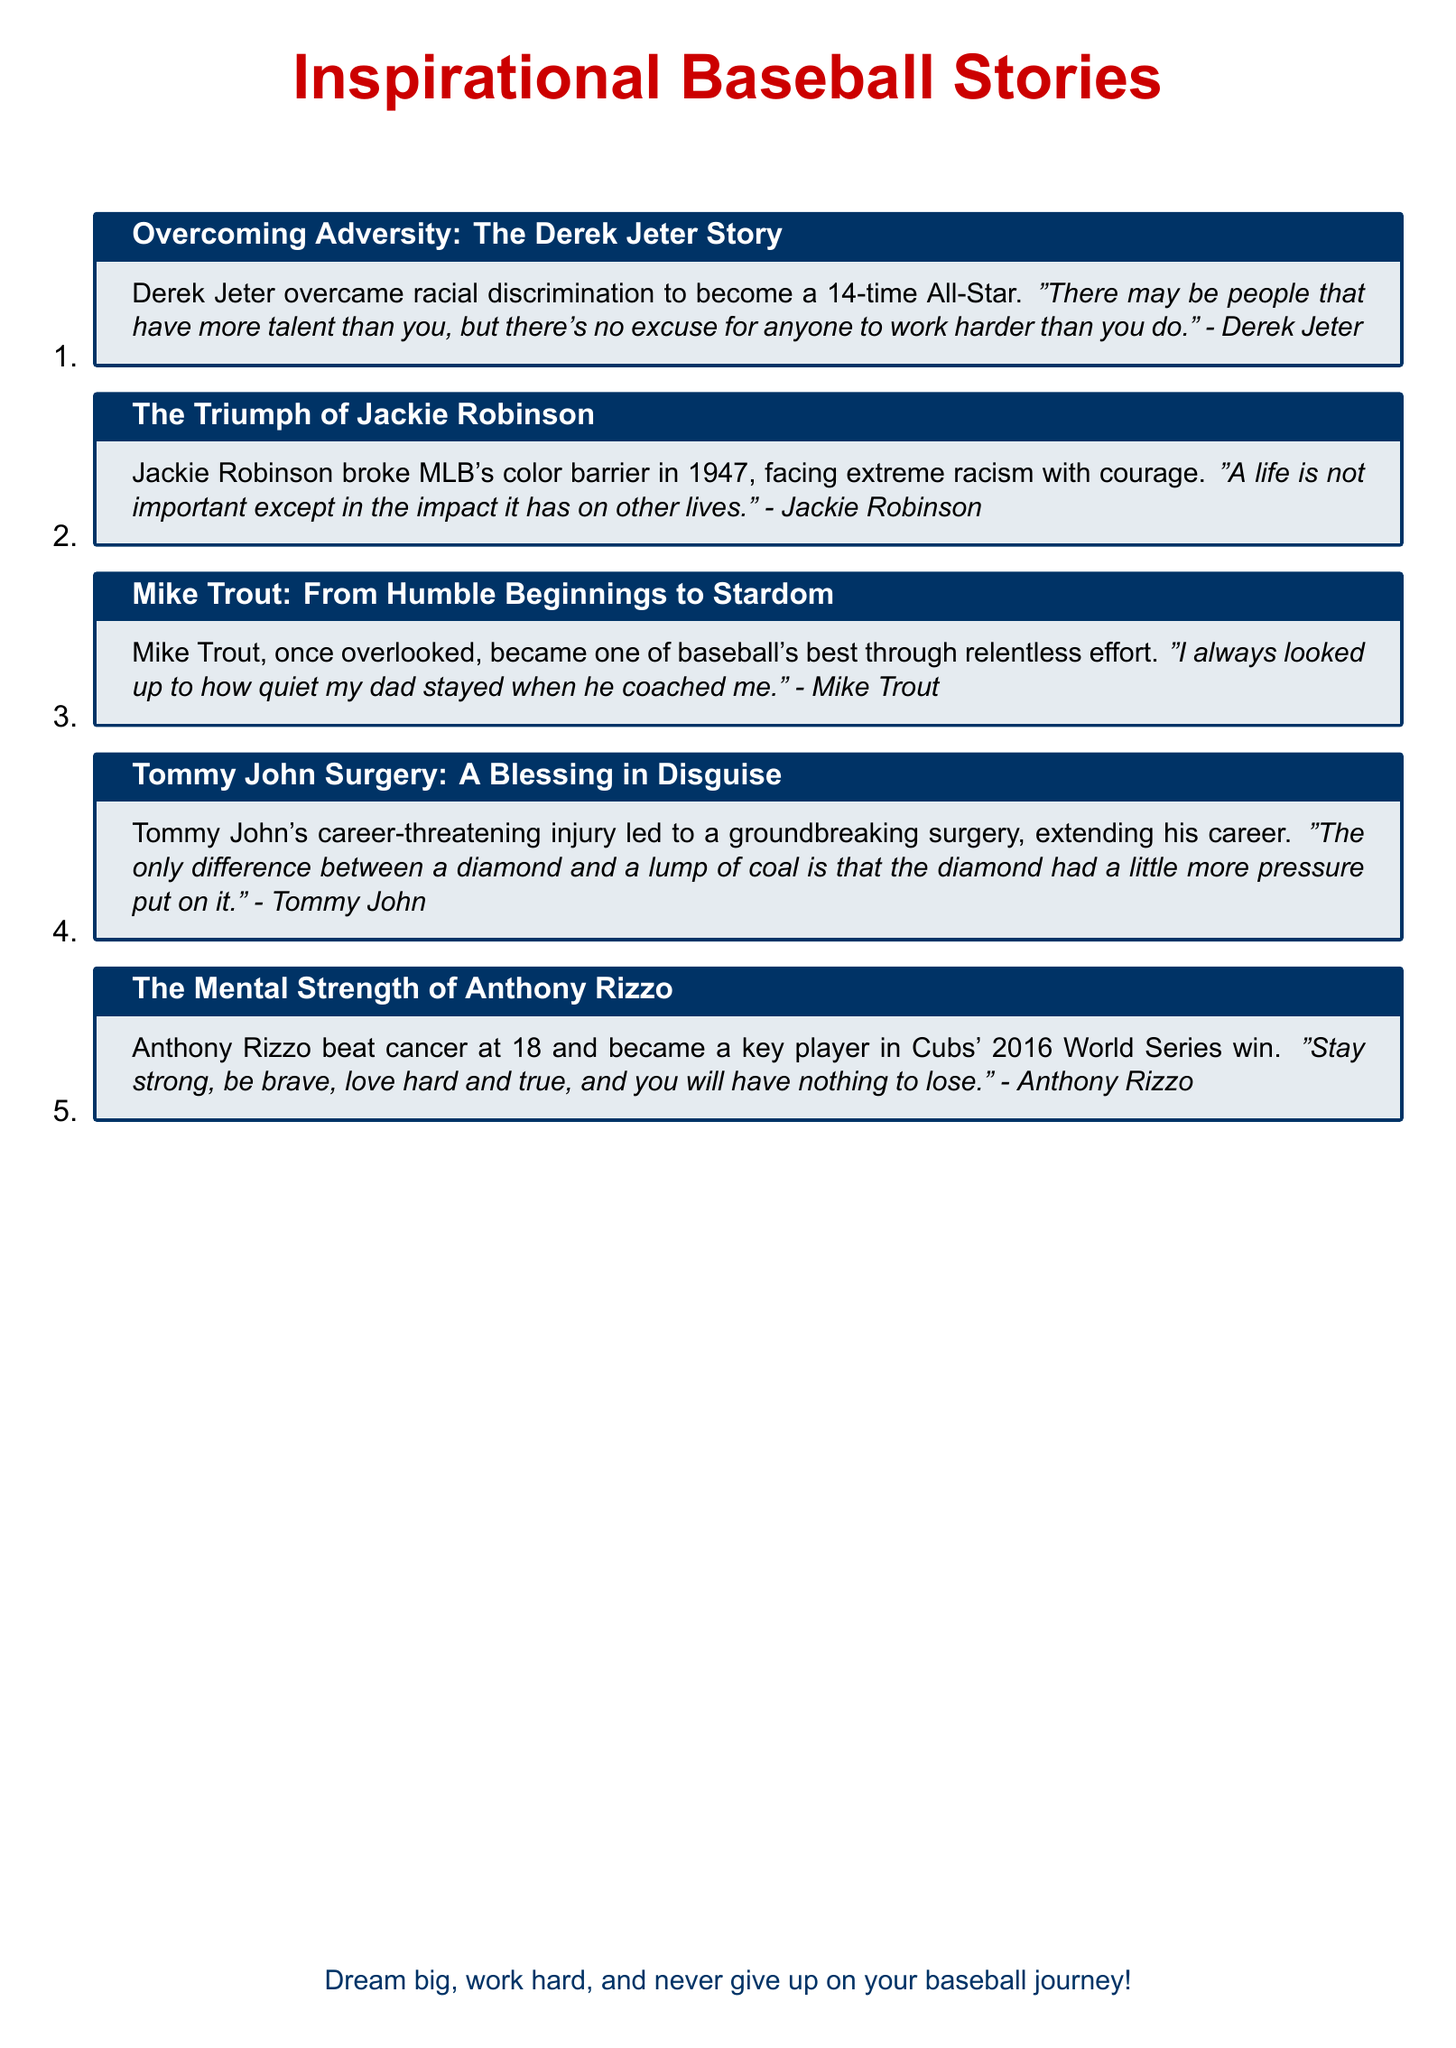What is the first story listed in the document? The first story listed is about Derek Jeter.
Answer: Derek Jeter Story How many All-Star selections did Derek Jeter achieve? The document states that Derek Jeter was a 14-time All-Star.
Answer: 14-time Who broke MLB's color barrier? The document mentions Jackie Robinson.
Answer: Jackie Robinson What significant surgery is mentioned in relation to Tommy John? The significant surgery mentioned is Tommy John Surgery.
Answer: Tommy John Surgery What did Anthony Rizzo overcome at the age of 18? Anthony Rizzo overcame cancer at the age of 18.
Answer: Cancer Who is known for saying "Dream big, work hard, and never give up on your baseball journey!"? This motivational quote is attributed to the overarching message of the document.
Answer: Overarching message What is the main theme of the stories mentioned in the document? The stories focus on overcoming adversity and challenges in baseball.
Answer: Overcoming adversity Which player is referenced for their impact on the Cubs' World Series win? The document references Anthony Rizzo in relation to the Cubs' 2016 World Series win.
Answer: Anthony Rizzo What lesson does Tommy John highlight with his quote about diamonds? The lesson highlighted is about enduring pressure and becoming stronger.
Answer: Pressure and strength 